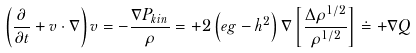Convert formula to latex. <formula><loc_0><loc_0><loc_500><loc_500>\left ( \frac { \partial } { \partial t } + v \cdot \nabla \right ) v = - \frac { \nabla P _ { k i n } } { \rho } = + 2 \left ( e g - h ^ { 2 } \right ) \nabla \left [ \frac { \Delta \rho ^ { 1 / 2 } } { \rho ^ { 1 / 2 } } \right ] \doteq + \nabla Q</formula> 